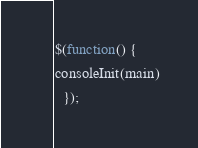Convert code to text. <code><loc_0><loc_0><loc_500><loc_500><_JavaScript_>
$(function() {
consoleInit(main)
  });
</code> 